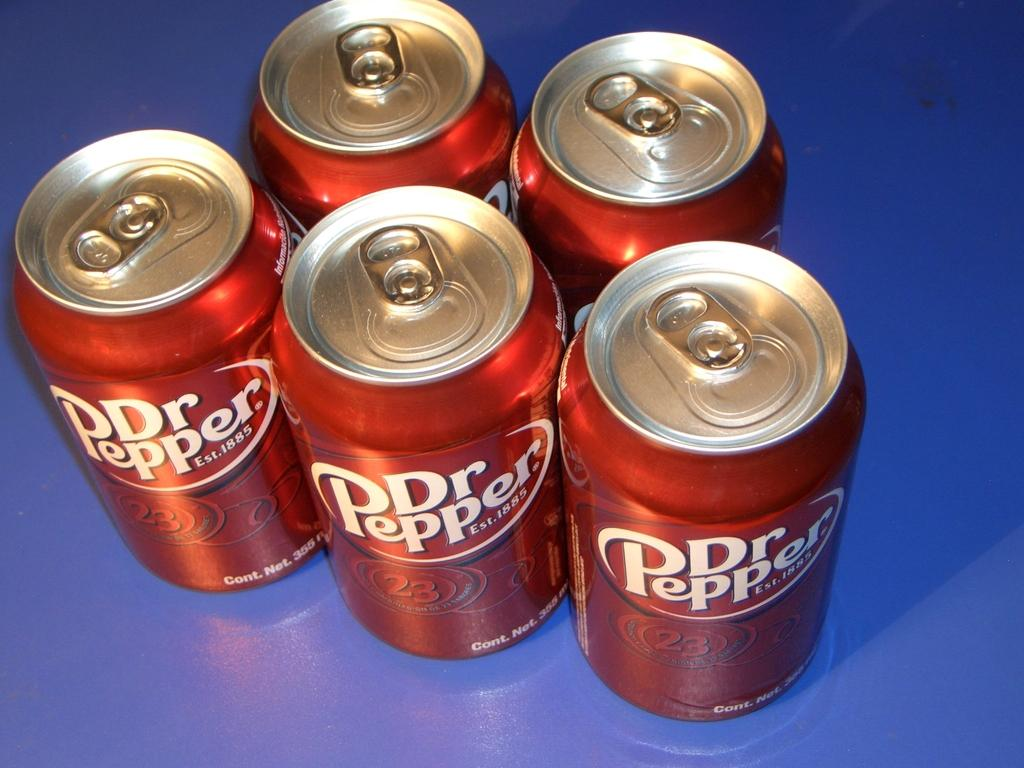<image>
Render a clear and concise summary of the photo. Five cans of Dr.Pepper on a blue counter/table. 